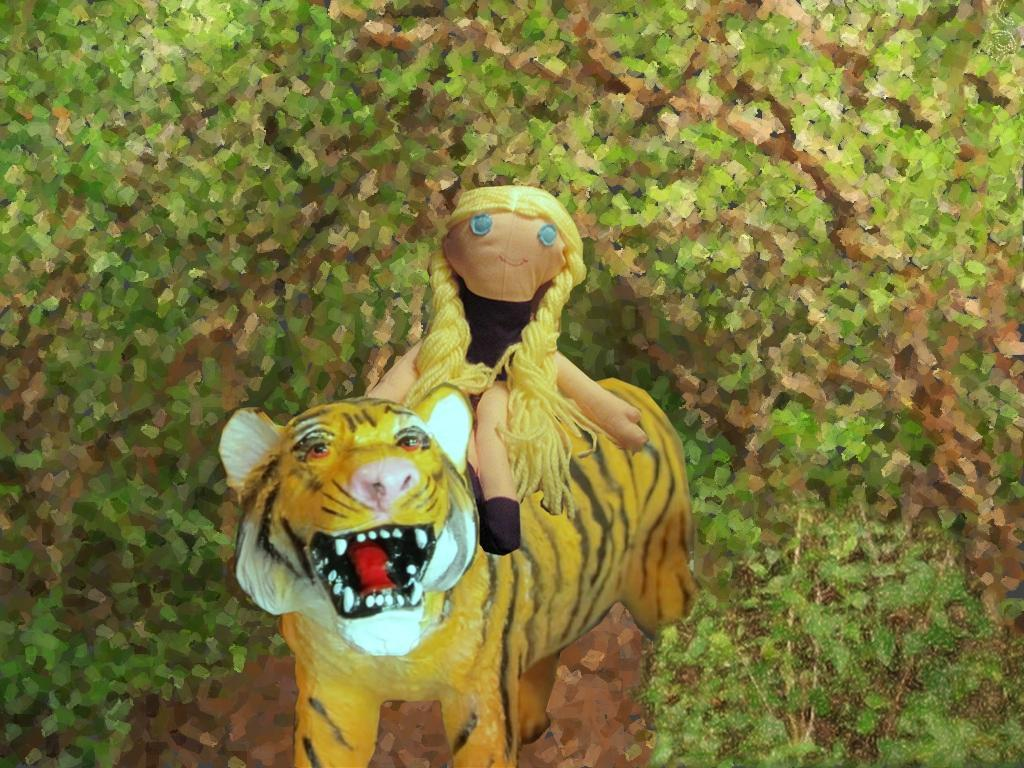What type of toy is depicted in the image? There is a toy of a girl in the image. What is the girl toy sitting on? The toy of the girl is sitting on a tiger toy. What can be seen in the background of the image? There are trees in the background of the image. How many frogs are sitting on the tiger toy with the girl toy in the image? There are no frogs present in the image; it only features the girl toy sitting on a tiger toy. 